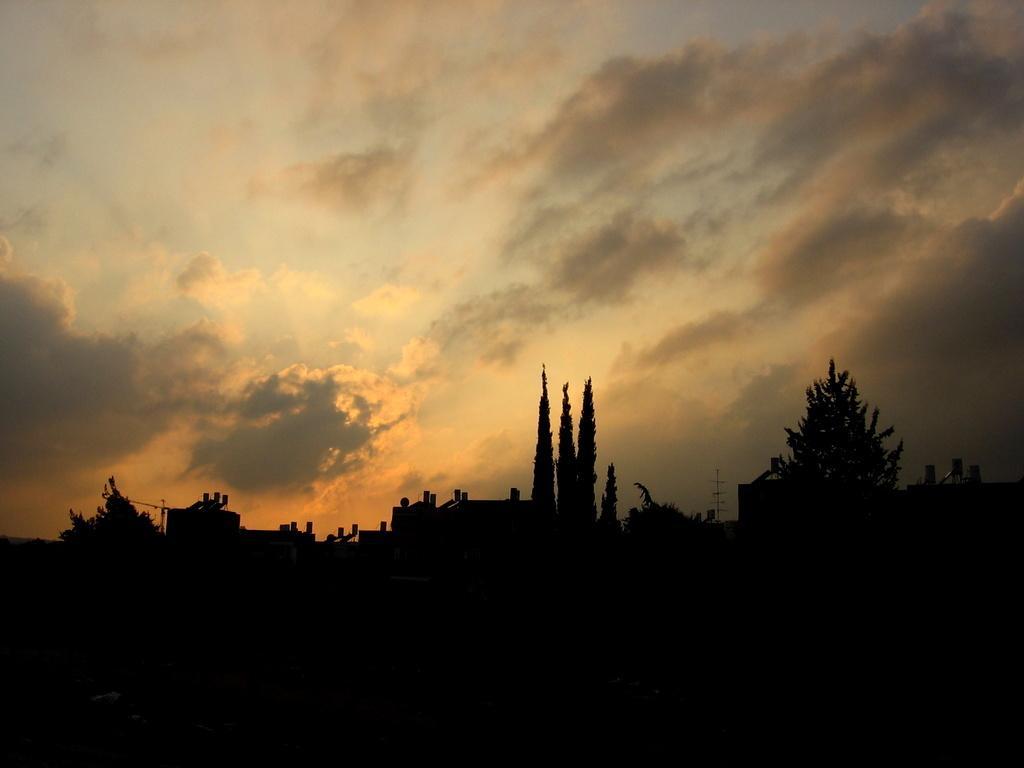Please provide a concise description of this image. In this picture I can see the trees and building in front and I see that it is dark. In the background I can see the sky which is cloudy. 